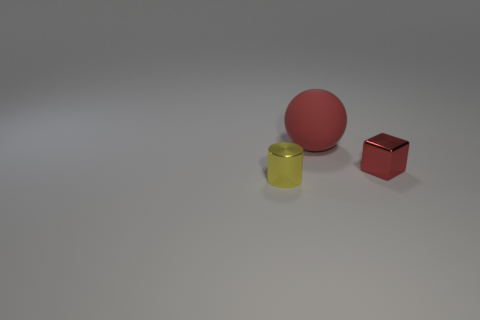Subtract 1 balls. How many balls are left? 0 Add 3 small objects. How many objects exist? 6 Subtract all cylinders. How many objects are left? 2 Subtract all green cylinders. Subtract all blue spheres. How many cylinders are left? 1 Subtract all red cylinders. How many cyan blocks are left? 0 Subtract all tiny yellow metal cylinders. Subtract all brown blocks. How many objects are left? 2 Add 2 small blocks. How many small blocks are left? 3 Add 2 red spheres. How many red spheres exist? 3 Subtract 0 brown cubes. How many objects are left? 3 